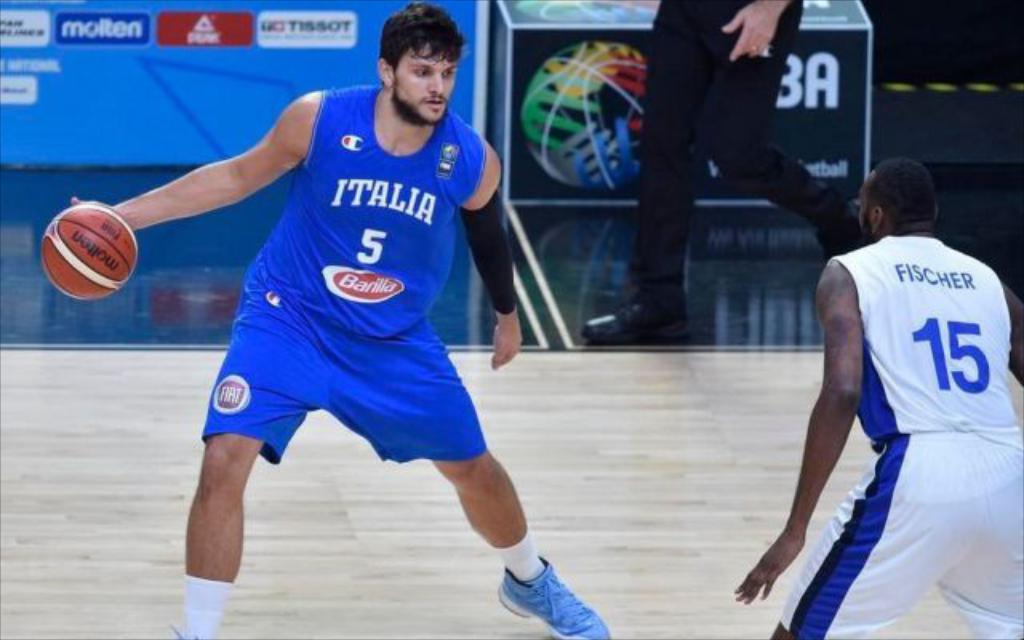What's the number on the white shirt?
Your answer should be very brief. 15. What number is on the blue jersey?
Your answer should be compact. 5. 